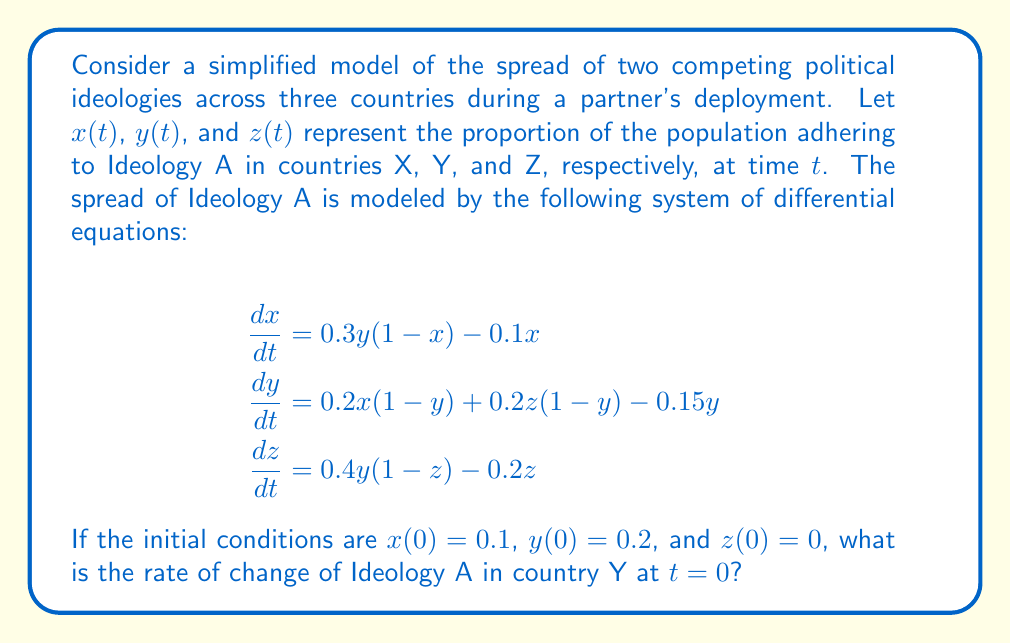Teach me how to tackle this problem. To solve this problem, we need to follow these steps:

1) We are given the system of differential equations, with $\frac{dy}{dt}$ representing the rate of change of Ideology A in country Y:

   $$\frac{dy}{dt} = 0.2x(1-y) + 0.2z(1-y) - 0.15y$$

2) We are asked to find $\frac{dy}{dt}$ at $t=0$, so we need to use the initial conditions:
   $x(0) = 0.1$, $y(0) = 0.2$, and $z(0) = 0$

3) Let's substitute these values into the equation:

   $$\begin{align*}
   \frac{dy}{dt}\bigg|_{t=0} &= 0.2(0.1)(1-0.2) + 0.2(0)(1-0.2) - 0.15(0.2) \\
   &= 0.2(0.1)(0.8) + 0 - 0.15(0.2)
   \end{align*}$$

4) Now let's calculate each term:
   
   $$\begin{align*}
   0.2(0.1)(0.8) &= 0.016 \\
   0.15(0.2) &= 0.03
   \end{align*}$$

5) Substituting these back into the equation:

   $$\frac{dy}{dt}\bigg|_{t=0} = 0.016 - 0.03 = -0.014$$

Therefore, the rate of change of Ideology A in country Y at $t=0$ is $-0.014$.
Answer: $-0.014$ 